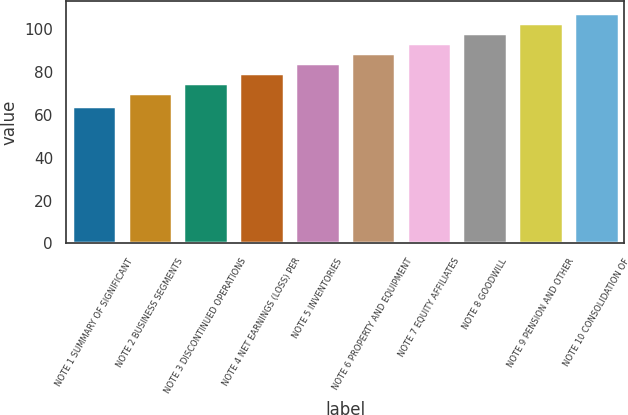Convert chart to OTSL. <chart><loc_0><loc_0><loc_500><loc_500><bar_chart><fcel>NOTE 1 SUMMARY OF SIGNIFICANT<fcel>NOTE 2 BUSINESS SEGMENTS<fcel>NOTE 3 DISCONTINUED OPERATIONS<fcel>NOTE 4 NET EARNINGS (LOSS) PER<fcel>NOTE 5 INVENTORIES<fcel>NOTE 6 PROPERTY AND EQUIPMENT<fcel>NOTE 7 EQUITY AFFILIATES<fcel>NOTE 8 GOODWILL<fcel>NOTE 9 PENSION AND OTHER<fcel>NOTE 10 CONSOLIDATION OF<nl><fcel>64<fcel>70<fcel>74.7<fcel>79.4<fcel>84.1<fcel>88.8<fcel>93.5<fcel>98.2<fcel>102.9<fcel>107.6<nl></chart> 